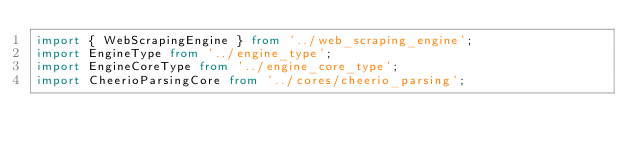<code> <loc_0><loc_0><loc_500><loc_500><_TypeScript_>import { WebScrapingEngine } from '../web_scraping_engine';
import EngineType from '../engine_type';
import EngineCoreType from '../engine_core_type';
import CheerioParsingCore from '../cores/cheerio_parsing';</code> 